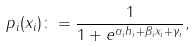<formula> <loc_0><loc_0><loc_500><loc_500>p _ { i } ( x _ { i } ) \colon = \frac { 1 } { 1 + e ^ { \alpha _ { i } h _ { i } + \beta _ { i } x _ { i } + \gamma _ { i } } } ,</formula> 